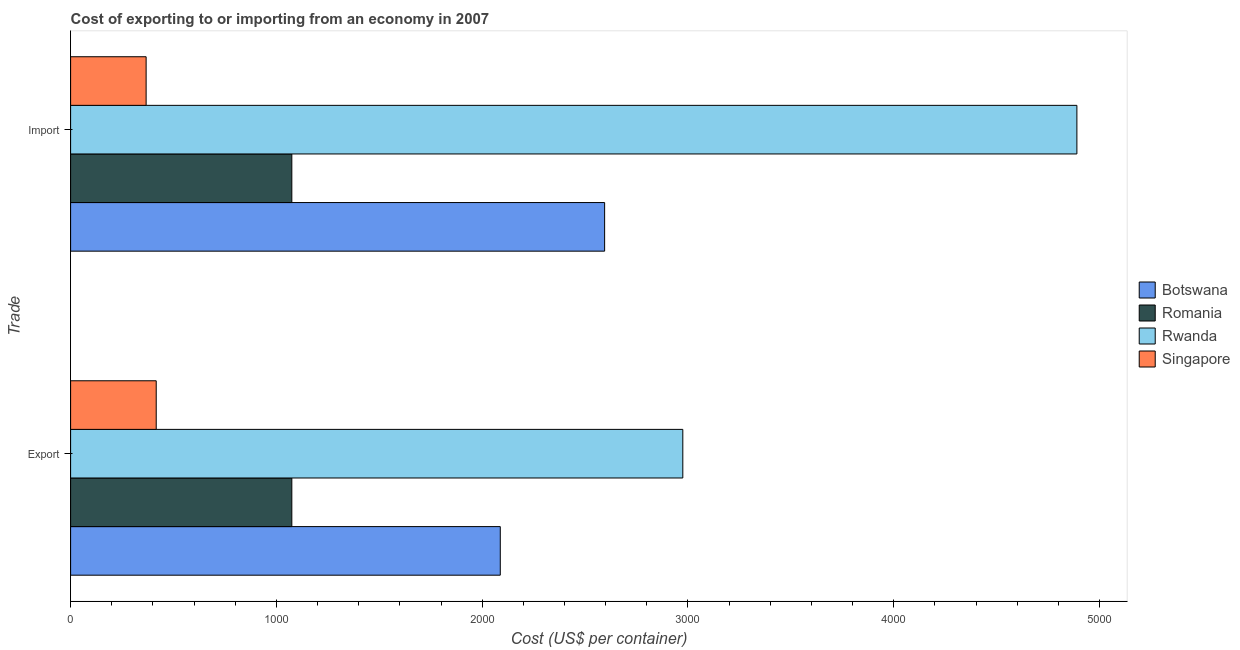How many different coloured bars are there?
Offer a very short reply. 4. How many bars are there on the 1st tick from the top?
Offer a very short reply. 4. What is the label of the 2nd group of bars from the top?
Offer a terse response. Export. What is the import cost in Singapore?
Ensure brevity in your answer.  367. Across all countries, what is the maximum export cost?
Make the answer very short. 2975. Across all countries, what is the minimum import cost?
Provide a short and direct response. 367. In which country was the export cost maximum?
Provide a short and direct response. Rwanda. In which country was the import cost minimum?
Your answer should be compact. Singapore. What is the total import cost in the graph?
Your answer should be very brief. 8927. What is the difference between the export cost in Singapore and that in Botswana?
Offer a very short reply. -1672. What is the difference between the export cost in Botswana and the import cost in Rwanda?
Provide a succinct answer. -2802. What is the average export cost per country?
Provide a short and direct response. 1638.5. What is the difference between the export cost and import cost in Botswana?
Ensure brevity in your answer.  -507. In how many countries, is the export cost greater than 4800 US$?
Ensure brevity in your answer.  0. What is the ratio of the import cost in Botswana to that in Rwanda?
Your response must be concise. 0.53. Is the import cost in Rwanda less than that in Romania?
Make the answer very short. No. What does the 4th bar from the top in Import represents?
Your response must be concise. Botswana. What does the 1st bar from the bottom in Import represents?
Provide a succinct answer. Botswana. How many bars are there?
Give a very brief answer. 8. Are all the bars in the graph horizontal?
Provide a succinct answer. Yes. How many countries are there in the graph?
Your response must be concise. 4. Does the graph contain any zero values?
Keep it short and to the point. No. Where does the legend appear in the graph?
Provide a succinct answer. Center right. How are the legend labels stacked?
Make the answer very short. Vertical. What is the title of the graph?
Your answer should be compact. Cost of exporting to or importing from an economy in 2007. Does "Mexico" appear as one of the legend labels in the graph?
Offer a terse response. No. What is the label or title of the X-axis?
Offer a very short reply. Cost (US$ per container). What is the label or title of the Y-axis?
Give a very brief answer. Trade. What is the Cost (US$ per container) in Botswana in Export?
Your response must be concise. 2088. What is the Cost (US$ per container) of Romania in Export?
Offer a very short reply. 1075. What is the Cost (US$ per container) of Rwanda in Export?
Offer a very short reply. 2975. What is the Cost (US$ per container) of Singapore in Export?
Offer a terse response. 416. What is the Cost (US$ per container) in Botswana in Import?
Offer a terse response. 2595. What is the Cost (US$ per container) of Romania in Import?
Offer a terse response. 1075. What is the Cost (US$ per container) of Rwanda in Import?
Make the answer very short. 4890. What is the Cost (US$ per container) in Singapore in Import?
Give a very brief answer. 367. Across all Trade, what is the maximum Cost (US$ per container) of Botswana?
Give a very brief answer. 2595. Across all Trade, what is the maximum Cost (US$ per container) of Romania?
Offer a terse response. 1075. Across all Trade, what is the maximum Cost (US$ per container) of Rwanda?
Provide a succinct answer. 4890. Across all Trade, what is the maximum Cost (US$ per container) in Singapore?
Your answer should be compact. 416. Across all Trade, what is the minimum Cost (US$ per container) in Botswana?
Make the answer very short. 2088. Across all Trade, what is the minimum Cost (US$ per container) in Romania?
Make the answer very short. 1075. Across all Trade, what is the minimum Cost (US$ per container) of Rwanda?
Provide a short and direct response. 2975. Across all Trade, what is the minimum Cost (US$ per container) in Singapore?
Ensure brevity in your answer.  367. What is the total Cost (US$ per container) in Botswana in the graph?
Make the answer very short. 4683. What is the total Cost (US$ per container) of Romania in the graph?
Ensure brevity in your answer.  2150. What is the total Cost (US$ per container) of Rwanda in the graph?
Keep it short and to the point. 7865. What is the total Cost (US$ per container) in Singapore in the graph?
Make the answer very short. 783. What is the difference between the Cost (US$ per container) of Botswana in Export and that in Import?
Ensure brevity in your answer.  -507. What is the difference between the Cost (US$ per container) in Rwanda in Export and that in Import?
Offer a very short reply. -1915. What is the difference between the Cost (US$ per container) of Botswana in Export and the Cost (US$ per container) of Romania in Import?
Provide a succinct answer. 1013. What is the difference between the Cost (US$ per container) of Botswana in Export and the Cost (US$ per container) of Rwanda in Import?
Give a very brief answer. -2802. What is the difference between the Cost (US$ per container) of Botswana in Export and the Cost (US$ per container) of Singapore in Import?
Give a very brief answer. 1721. What is the difference between the Cost (US$ per container) of Romania in Export and the Cost (US$ per container) of Rwanda in Import?
Ensure brevity in your answer.  -3815. What is the difference between the Cost (US$ per container) in Romania in Export and the Cost (US$ per container) in Singapore in Import?
Provide a succinct answer. 708. What is the difference between the Cost (US$ per container) in Rwanda in Export and the Cost (US$ per container) in Singapore in Import?
Offer a terse response. 2608. What is the average Cost (US$ per container) of Botswana per Trade?
Offer a terse response. 2341.5. What is the average Cost (US$ per container) in Romania per Trade?
Your response must be concise. 1075. What is the average Cost (US$ per container) in Rwanda per Trade?
Give a very brief answer. 3932.5. What is the average Cost (US$ per container) in Singapore per Trade?
Make the answer very short. 391.5. What is the difference between the Cost (US$ per container) of Botswana and Cost (US$ per container) of Romania in Export?
Provide a short and direct response. 1013. What is the difference between the Cost (US$ per container) of Botswana and Cost (US$ per container) of Rwanda in Export?
Your answer should be very brief. -887. What is the difference between the Cost (US$ per container) of Botswana and Cost (US$ per container) of Singapore in Export?
Your answer should be very brief. 1672. What is the difference between the Cost (US$ per container) of Romania and Cost (US$ per container) of Rwanda in Export?
Keep it short and to the point. -1900. What is the difference between the Cost (US$ per container) in Romania and Cost (US$ per container) in Singapore in Export?
Your answer should be very brief. 659. What is the difference between the Cost (US$ per container) of Rwanda and Cost (US$ per container) of Singapore in Export?
Provide a succinct answer. 2559. What is the difference between the Cost (US$ per container) in Botswana and Cost (US$ per container) in Romania in Import?
Give a very brief answer. 1520. What is the difference between the Cost (US$ per container) in Botswana and Cost (US$ per container) in Rwanda in Import?
Your response must be concise. -2295. What is the difference between the Cost (US$ per container) in Botswana and Cost (US$ per container) in Singapore in Import?
Offer a terse response. 2228. What is the difference between the Cost (US$ per container) in Romania and Cost (US$ per container) in Rwanda in Import?
Your answer should be compact. -3815. What is the difference between the Cost (US$ per container) in Romania and Cost (US$ per container) in Singapore in Import?
Your answer should be very brief. 708. What is the difference between the Cost (US$ per container) of Rwanda and Cost (US$ per container) of Singapore in Import?
Provide a short and direct response. 4523. What is the ratio of the Cost (US$ per container) in Botswana in Export to that in Import?
Your answer should be very brief. 0.8. What is the ratio of the Cost (US$ per container) of Rwanda in Export to that in Import?
Your response must be concise. 0.61. What is the ratio of the Cost (US$ per container) in Singapore in Export to that in Import?
Keep it short and to the point. 1.13. What is the difference between the highest and the second highest Cost (US$ per container) of Botswana?
Your response must be concise. 507. What is the difference between the highest and the second highest Cost (US$ per container) of Rwanda?
Ensure brevity in your answer.  1915. What is the difference between the highest and the lowest Cost (US$ per container) in Botswana?
Your answer should be very brief. 507. What is the difference between the highest and the lowest Cost (US$ per container) of Romania?
Give a very brief answer. 0. What is the difference between the highest and the lowest Cost (US$ per container) in Rwanda?
Keep it short and to the point. 1915. 